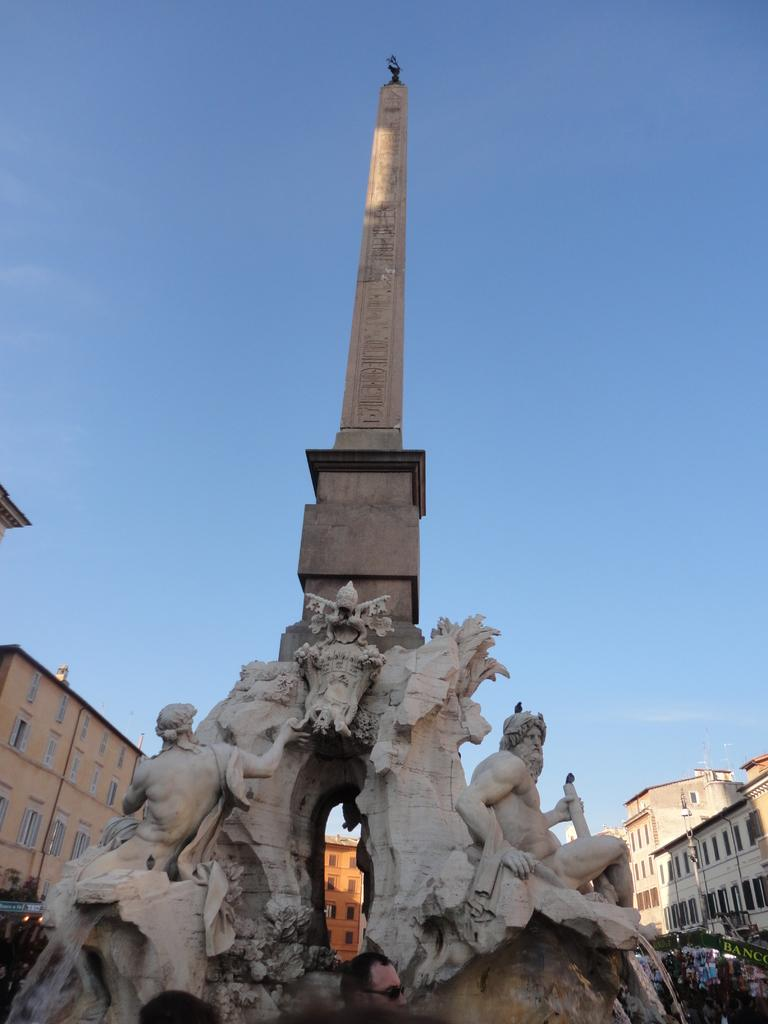What is the main structure in the center of the image? There is a tower in the center of the image. What can be seen at the bottom of the image? Sculptures are present at the bottom of the image. What type of structures are visible in the background of the image? There are buildings in the background of the image. What is visible in the sky in the background of the image? The sky is visible in the background of the image. What type of food is being served on the plane in the image? There is no plane present in the image, so no food is being served. What type of nut is used to create the sculptures at the bottom of the image? The sculptures are not made of nuts; they are separate entities from the nut topic. 